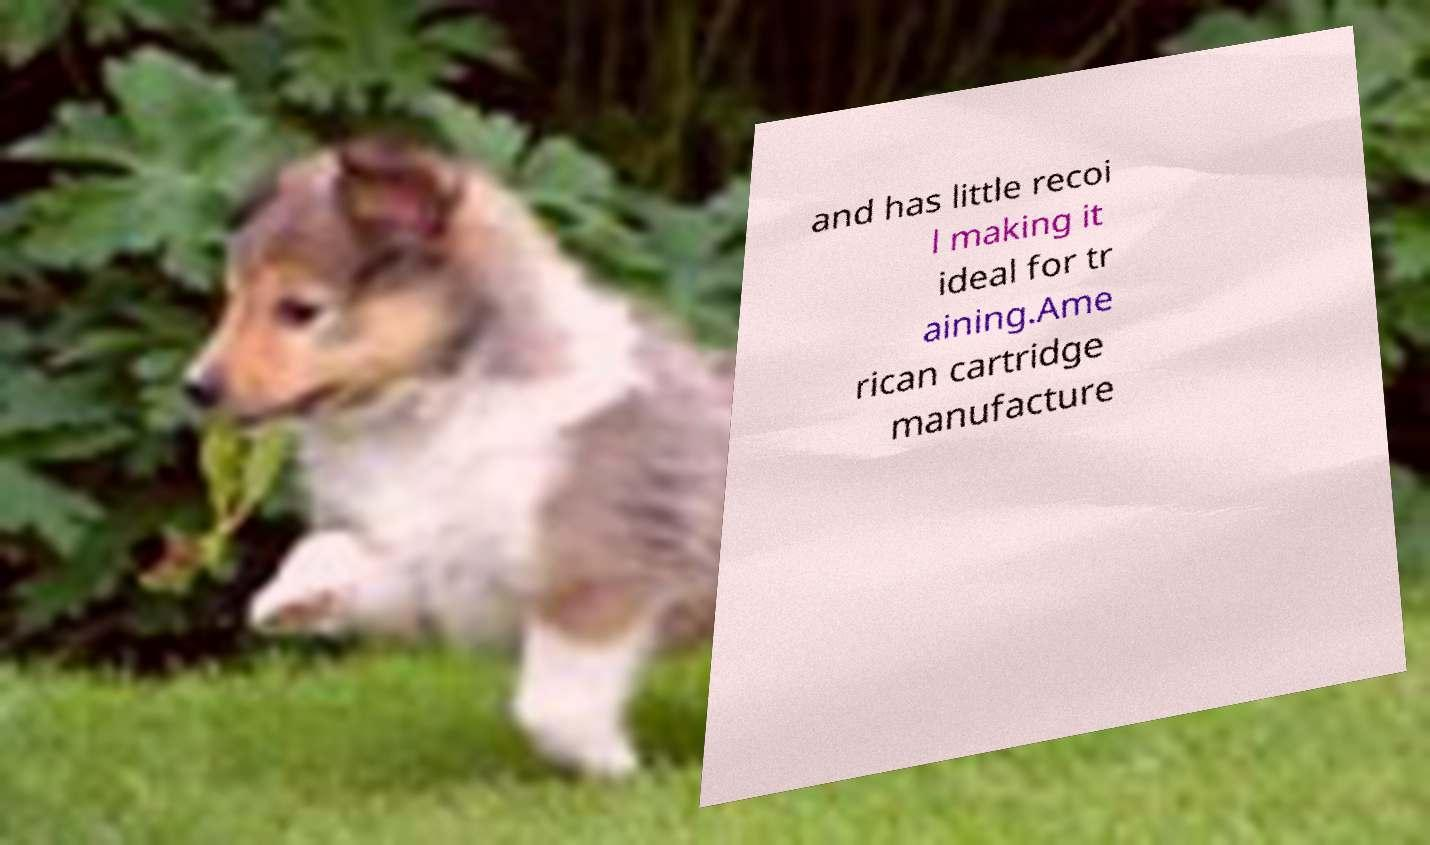I need the written content from this picture converted into text. Can you do that? and has little recoi l making it ideal for tr aining.Ame rican cartridge manufacture 